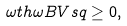Convert formula to latex. <formula><loc_0><loc_0><loc_500><loc_500>\omega t h \omega B V s q \geq 0 ,</formula> 